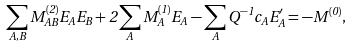Convert formula to latex. <formula><loc_0><loc_0><loc_500><loc_500>\sum _ { A , B } M ^ { ( 2 ) } _ { A B } E _ { A } E _ { B } + 2 \sum _ { A } M ^ { ( 1 ) } _ { A } E _ { A } - \sum _ { A } Q ^ { - 1 } c _ { A } E _ { A } ^ { \prime } = - M ^ { ( 0 ) } ,</formula> 